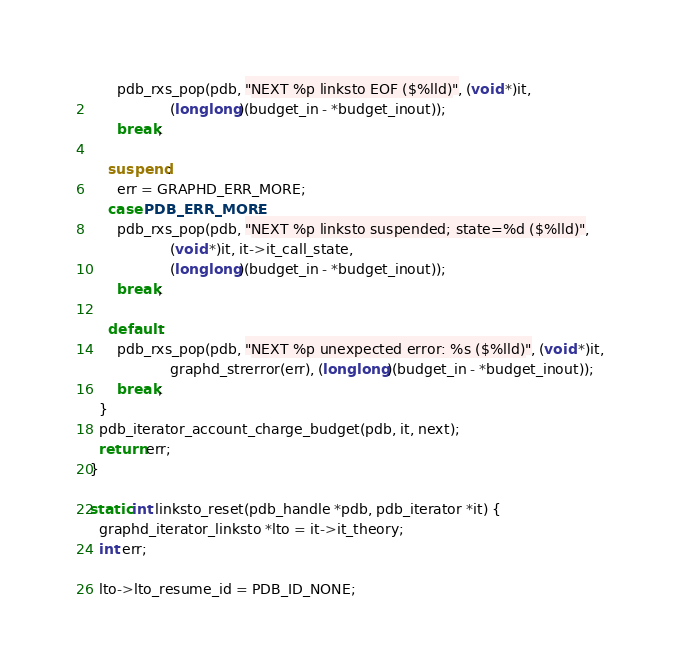<code> <loc_0><loc_0><loc_500><loc_500><_C_>      pdb_rxs_pop(pdb, "NEXT %p linksto EOF ($%lld)", (void *)it,
                  (long long)(budget_in - *budget_inout));
      break;

    suspend:
      err = GRAPHD_ERR_MORE;
    case PDB_ERR_MORE:
      pdb_rxs_pop(pdb, "NEXT %p linksto suspended; state=%d ($%lld)",
                  (void *)it, it->it_call_state,
                  (long long)(budget_in - *budget_inout));
      break;

    default:
      pdb_rxs_pop(pdb, "NEXT %p unexpected error: %s ($%lld)", (void *)it,
                  graphd_strerror(err), (long long)(budget_in - *budget_inout));
      break;
  }
  pdb_iterator_account_charge_budget(pdb, it, next);
  return err;
}

static int linksto_reset(pdb_handle *pdb, pdb_iterator *it) {
  graphd_iterator_linksto *lto = it->it_theory;
  int err;

  lto->lto_resume_id = PDB_ID_NONE;</code> 